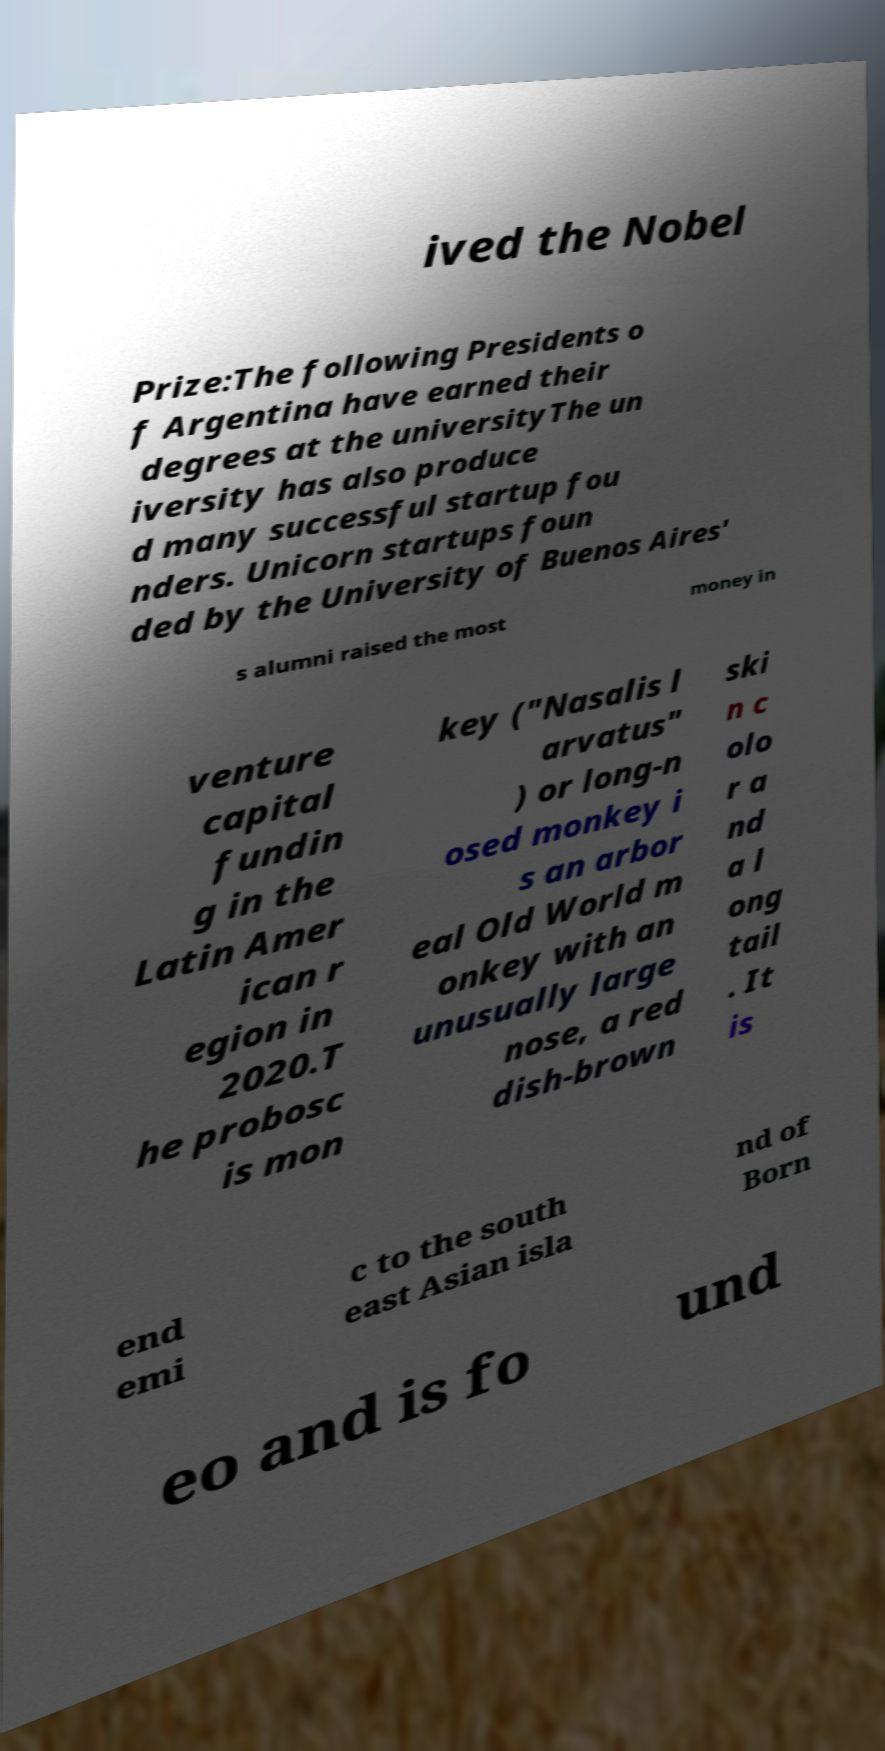Could you assist in decoding the text presented in this image and type it out clearly? ived the Nobel Prize:The following Presidents o f Argentina have earned their degrees at the universityThe un iversity has also produce d many successful startup fou nders. Unicorn startups foun ded by the University of Buenos Aires' s alumni raised the most money in venture capital fundin g in the Latin Amer ican r egion in 2020.T he probosc is mon key ("Nasalis l arvatus" ) or long-n osed monkey i s an arbor eal Old World m onkey with an unusually large nose, a red dish-brown ski n c olo r a nd a l ong tail . It is end emi c to the south east Asian isla nd of Born eo and is fo und 